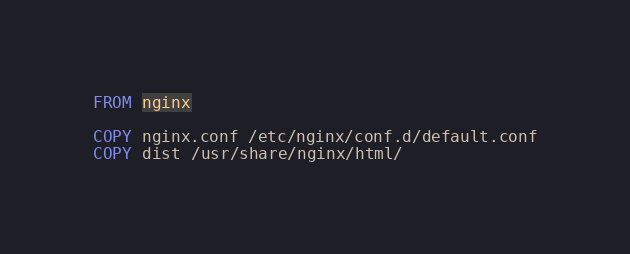Convert code to text. <code><loc_0><loc_0><loc_500><loc_500><_Dockerfile_>FROM nginx

COPY nginx.conf /etc/nginx/conf.d/default.conf
COPY dist /usr/share/nginx/html/
</code> 